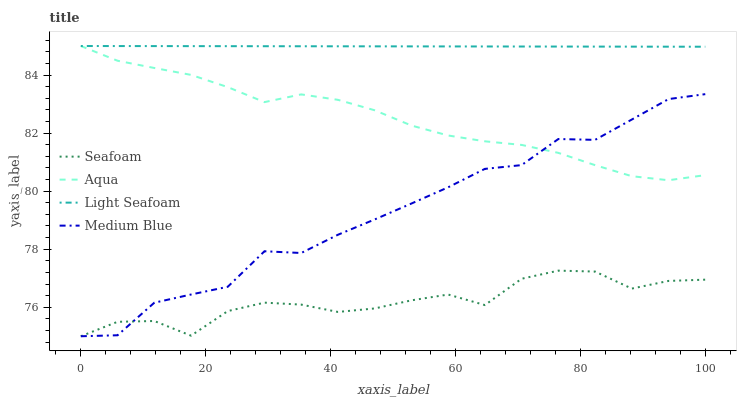Does Seafoam have the minimum area under the curve?
Answer yes or no. Yes. Does Light Seafoam have the maximum area under the curve?
Answer yes or no. Yes. Does Aqua have the minimum area under the curve?
Answer yes or no. No. Does Aqua have the maximum area under the curve?
Answer yes or no. No. Is Light Seafoam the smoothest?
Answer yes or no. Yes. Is Medium Blue the roughest?
Answer yes or no. Yes. Is Aqua the smoothest?
Answer yes or no. No. Is Aqua the roughest?
Answer yes or no. No. Does Aqua have the lowest value?
Answer yes or no. No. Does Seafoam have the highest value?
Answer yes or no. No. Is Seafoam less than Aqua?
Answer yes or no. Yes. Is Light Seafoam greater than Medium Blue?
Answer yes or no. Yes. Does Seafoam intersect Aqua?
Answer yes or no. No. 